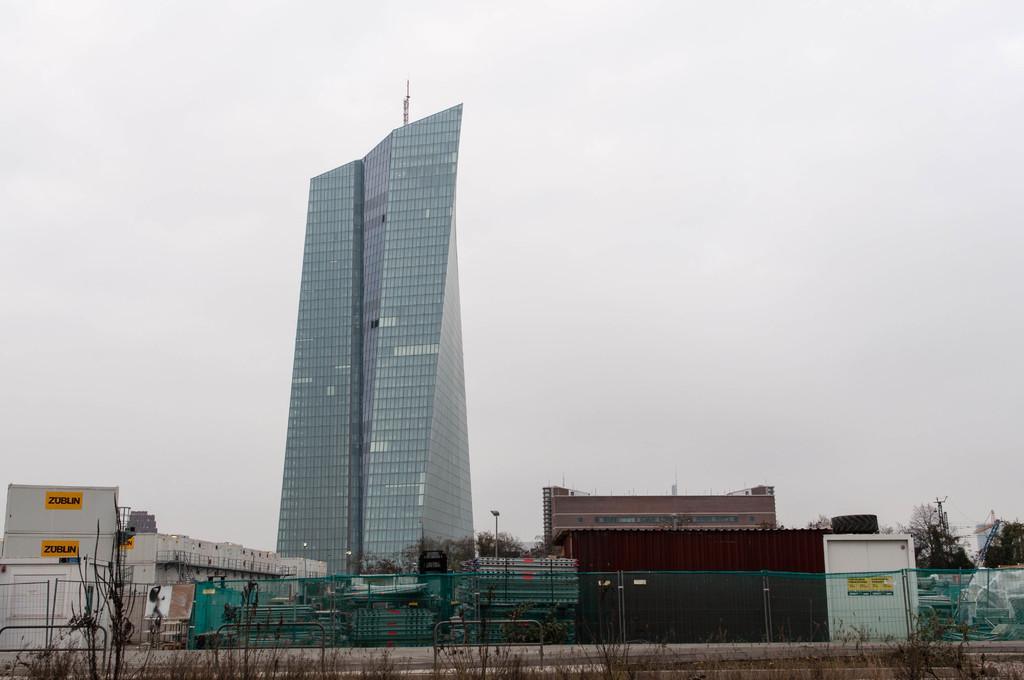In one or two sentences, can you explain what this image depicts? In this picture we can see a tall building made of glass pieces. This building is surrounded by small houses and trees. 